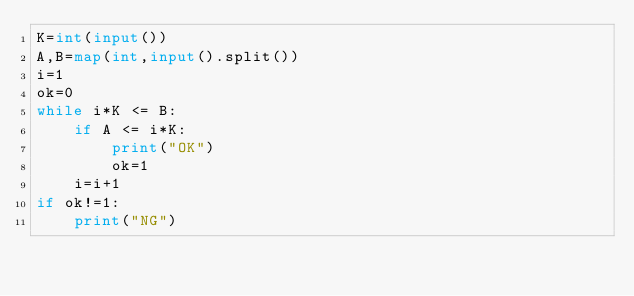<code> <loc_0><loc_0><loc_500><loc_500><_Python_>K=int(input())
A,B=map(int,input().split())
i=1
ok=0
while i*K <= B:
    if A <= i*K:
        print("OK")
        ok=1
    i=i+1
if ok!=1:
    print("NG")</code> 